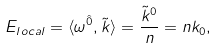<formula> <loc_0><loc_0><loc_500><loc_500>E _ { l o c a l } = \langle \omega ^ { \hat { 0 } } , \tilde { k } \rangle = \frac { \tilde { k } ^ { 0 } } { n } = n k _ { 0 } ,</formula> 